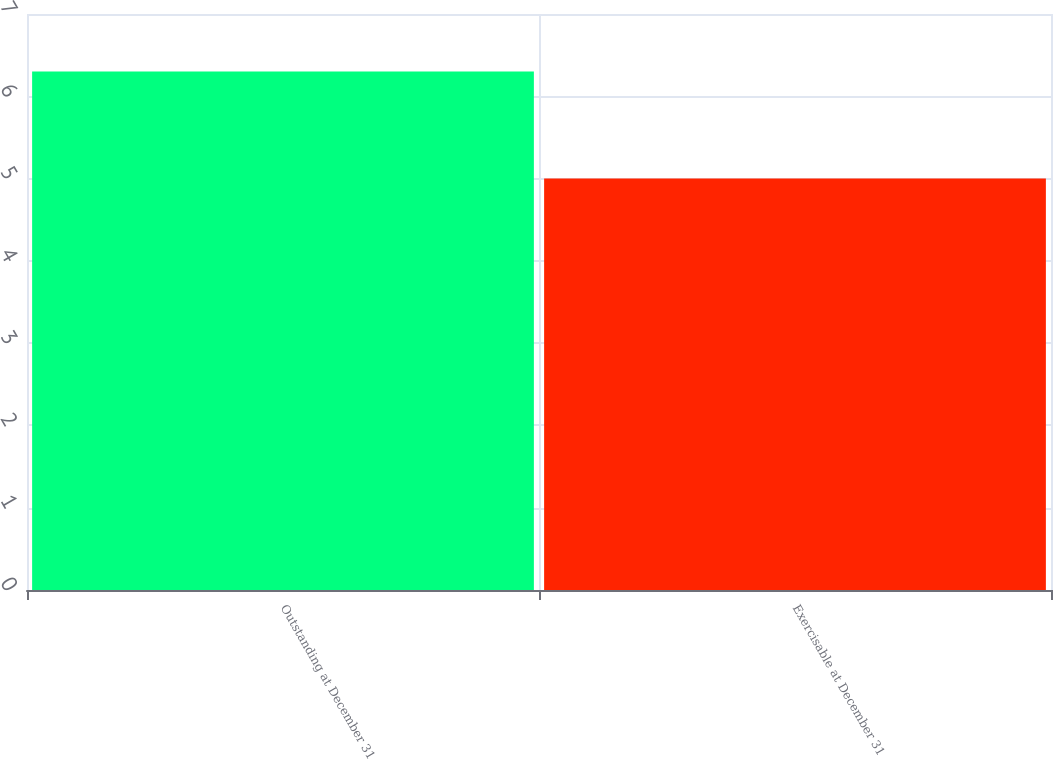Convert chart. <chart><loc_0><loc_0><loc_500><loc_500><bar_chart><fcel>Outstanding at December 31<fcel>Exercisable at December 31<nl><fcel>6.3<fcel>5<nl></chart> 